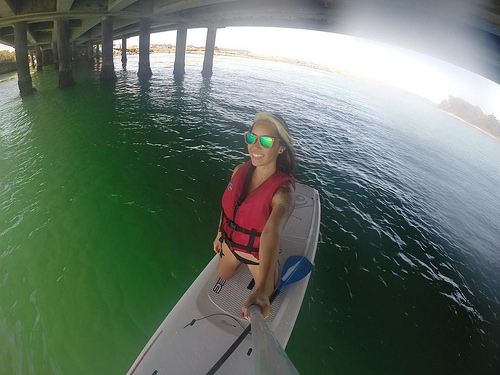<image>
Is the girl on the water? Yes. Looking at the image, I can see the girl is positioned on top of the water, with the water providing support. 